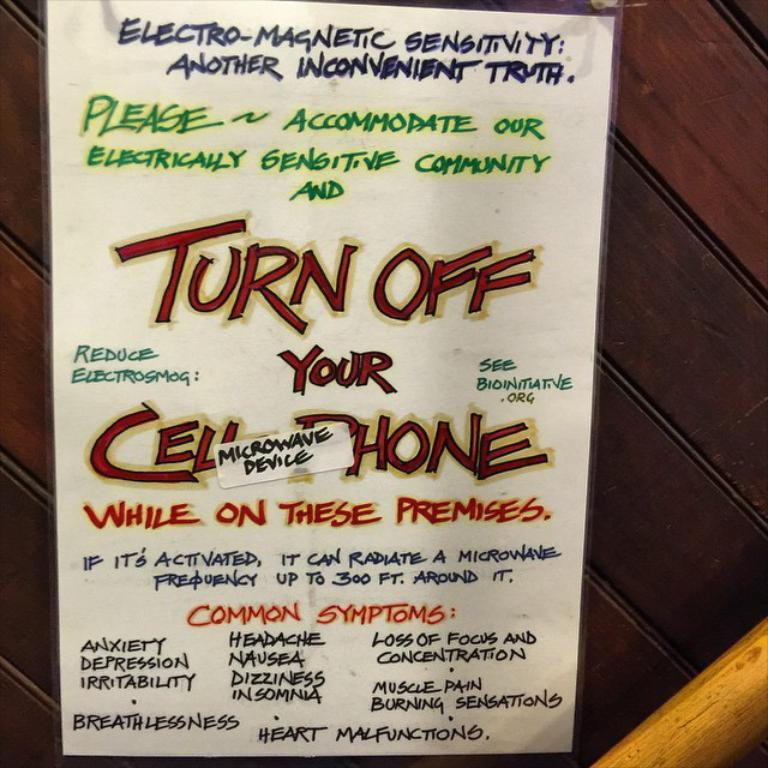<image>
Present a compact description of the photo's key features. a poster on a wall that says 'turn off your cell phone' on it 